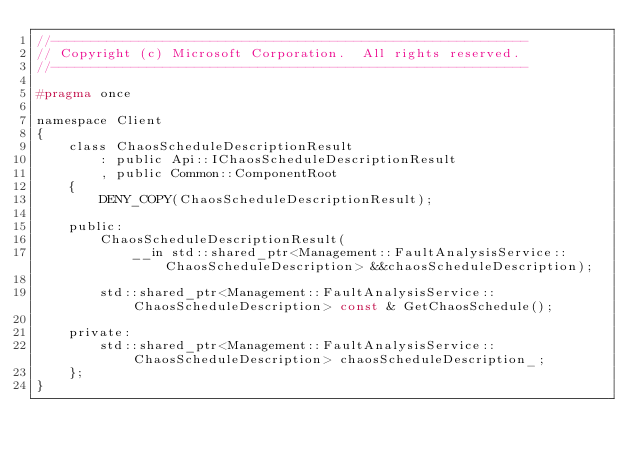<code> <loc_0><loc_0><loc_500><loc_500><_C_>//------------------------------------------------------------
// Copyright (c) Microsoft Corporation.  All rights reserved.
//------------------------------------------------------------

#pragma once

namespace Client
{
    class ChaosScheduleDescriptionResult
        : public Api::IChaosScheduleDescriptionResult
        , public Common::ComponentRoot
    {
        DENY_COPY(ChaosScheduleDescriptionResult);

    public:
        ChaosScheduleDescriptionResult(
            __in std::shared_ptr<Management::FaultAnalysisService::ChaosScheduleDescription> &&chaosScheduleDescription);

        std::shared_ptr<Management::FaultAnalysisService::ChaosScheduleDescription> const & GetChaosSchedule();

    private:
        std::shared_ptr<Management::FaultAnalysisService::ChaosScheduleDescription> chaosScheduleDescription_;
    };
}
</code> 